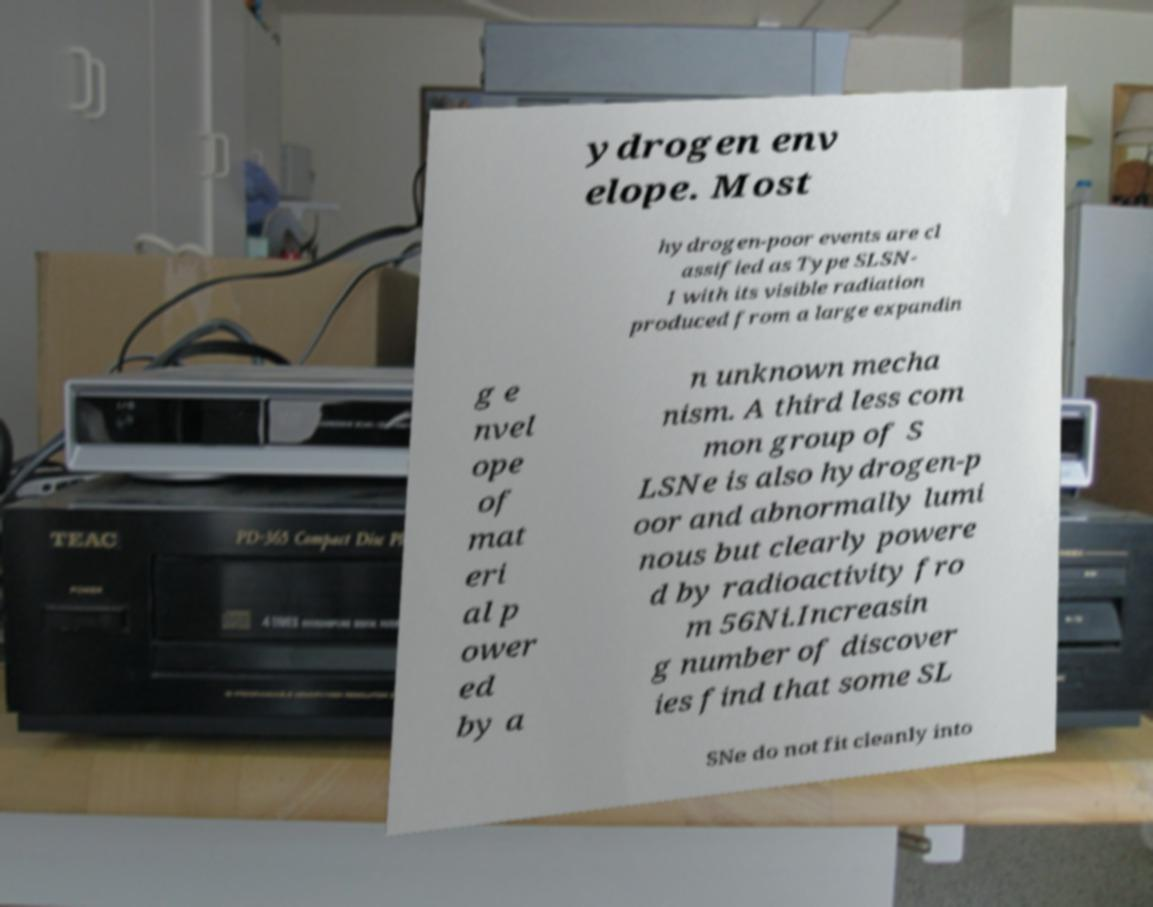Can you read and provide the text displayed in the image?This photo seems to have some interesting text. Can you extract and type it out for me? ydrogen env elope. Most hydrogen-poor events are cl assified as Type SLSN- I with its visible radiation produced from a large expandin g e nvel ope of mat eri al p ower ed by a n unknown mecha nism. A third less com mon group of S LSNe is also hydrogen-p oor and abnormally lumi nous but clearly powere d by radioactivity fro m 56Ni.Increasin g number of discover ies find that some SL SNe do not fit cleanly into 